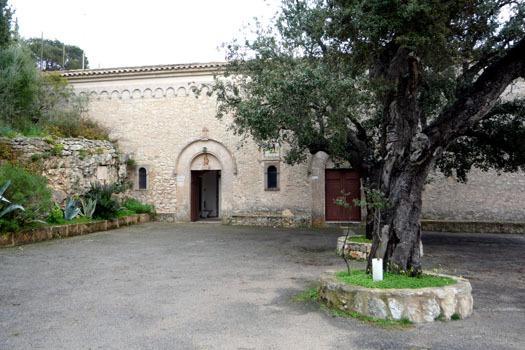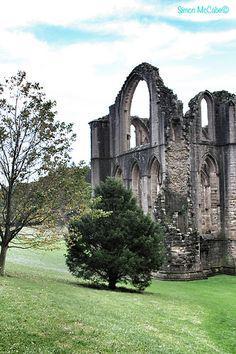The first image is the image on the left, the second image is the image on the right. For the images shown, is this caption "One building features three arches topped by a circle over the main archway entrance." true? Answer yes or no. No. 